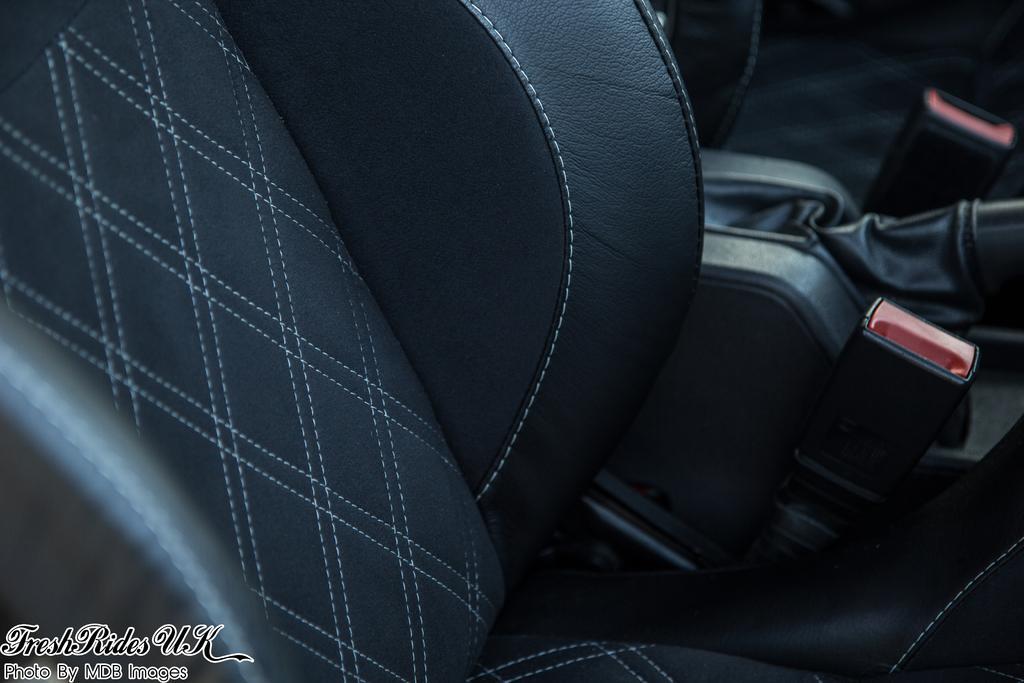Describe this image in one or two sentences. In the bottom left, there is a watermark. In the background, there is a seat. And the background is blurred. 